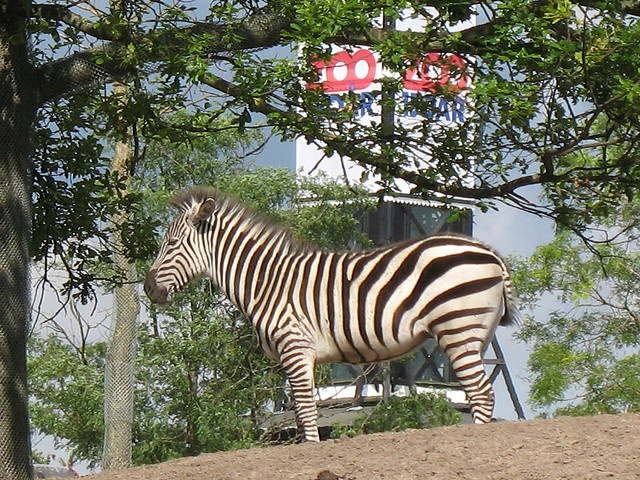Describe the objects in this image and their specific colors. I can see a zebra in black, beige, maroon, and gray tones in this image. 